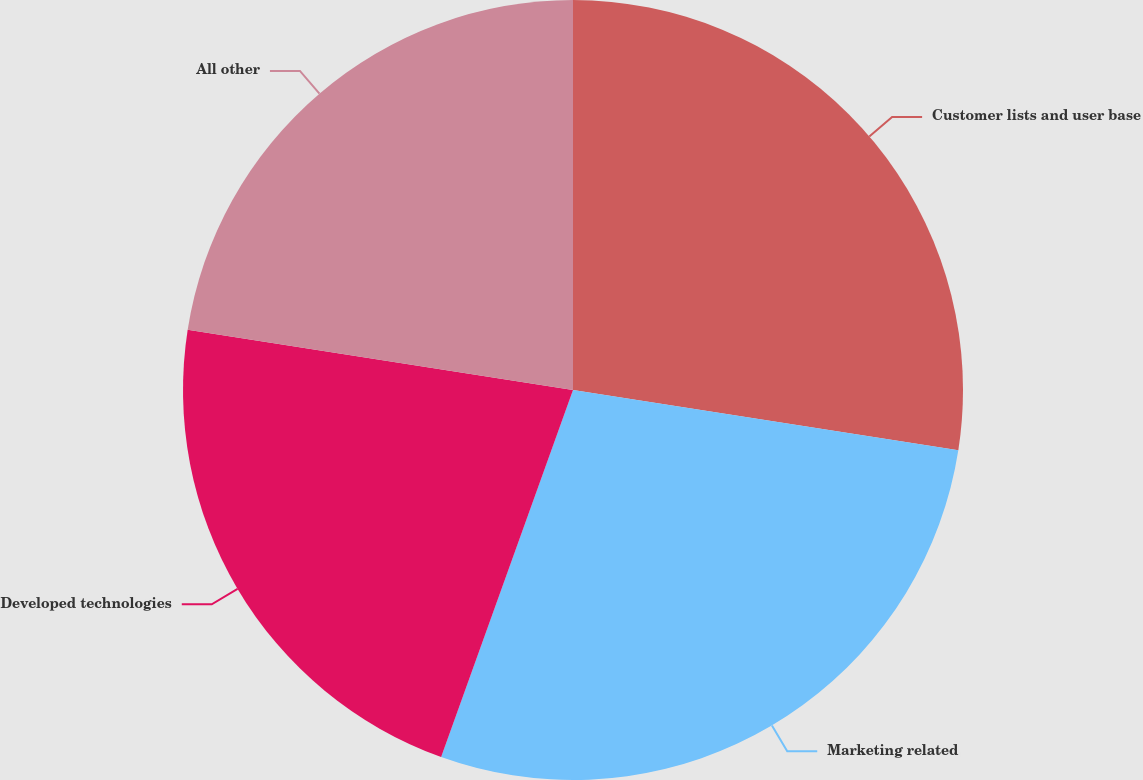Convert chart. <chart><loc_0><loc_0><loc_500><loc_500><pie_chart><fcel>Customer lists and user base<fcel>Marketing related<fcel>Developed technologies<fcel>All other<nl><fcel>27.47%<fcel>28.02%<fcel>21.98%<fcel>22.53%<nl></chart> 